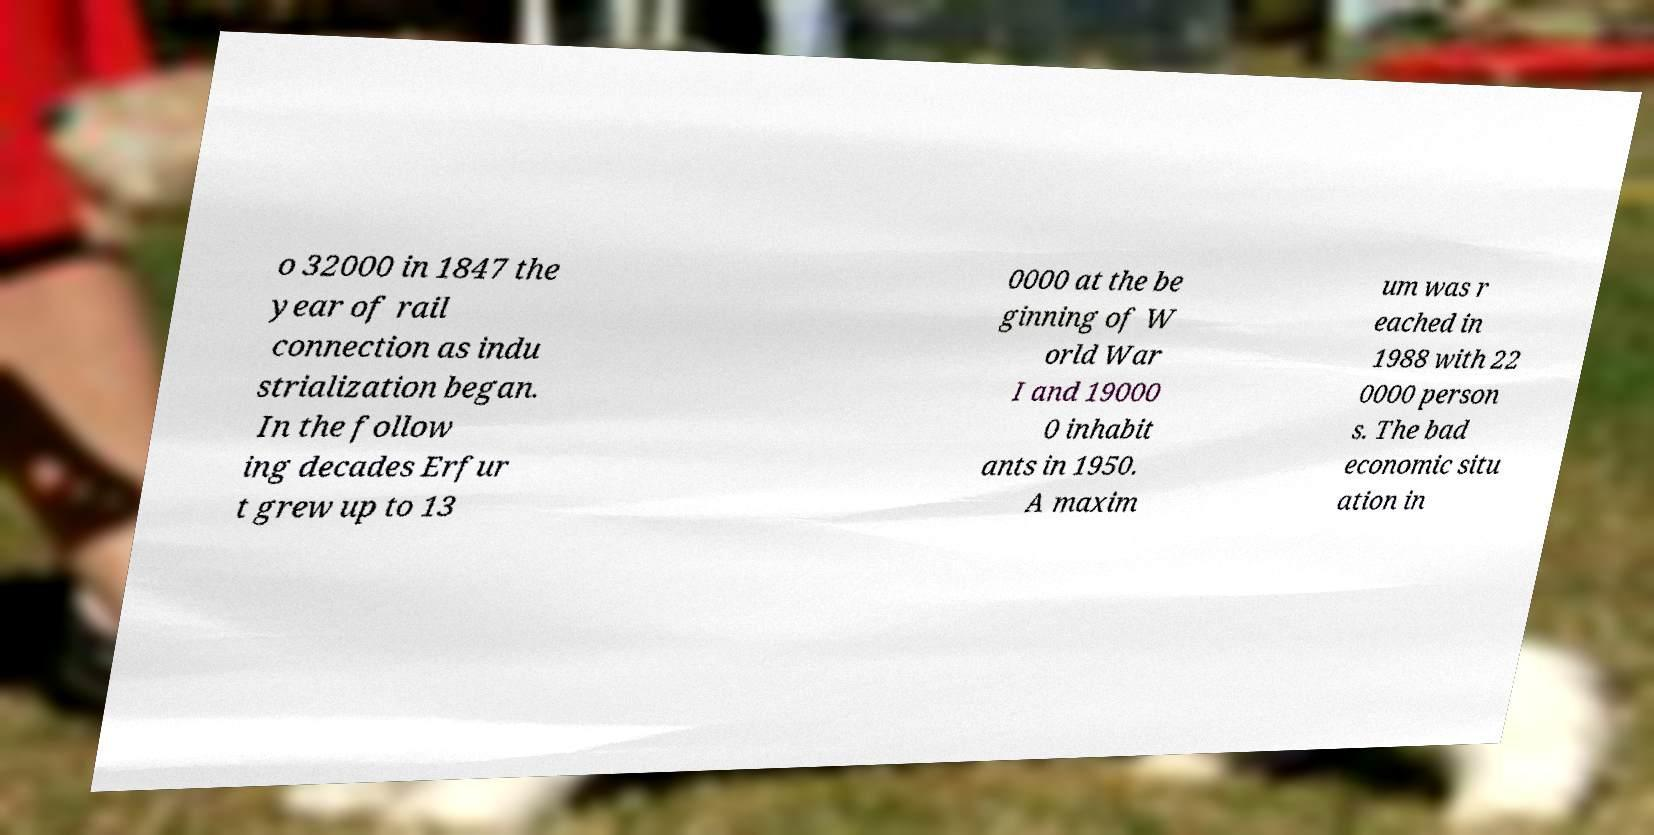Please identify and transcribe the text found in this image. o 32000 in 1847 the year of rail connection as indu strialization began. In the follow ing decades Erfur t grew up to 13 0000 at the be ginning of W orld War I and 19000 0 inhabit ants in 1950. A maxim um was r eached in 1988 with 22 0000 person s. The bad economic situ ation in 